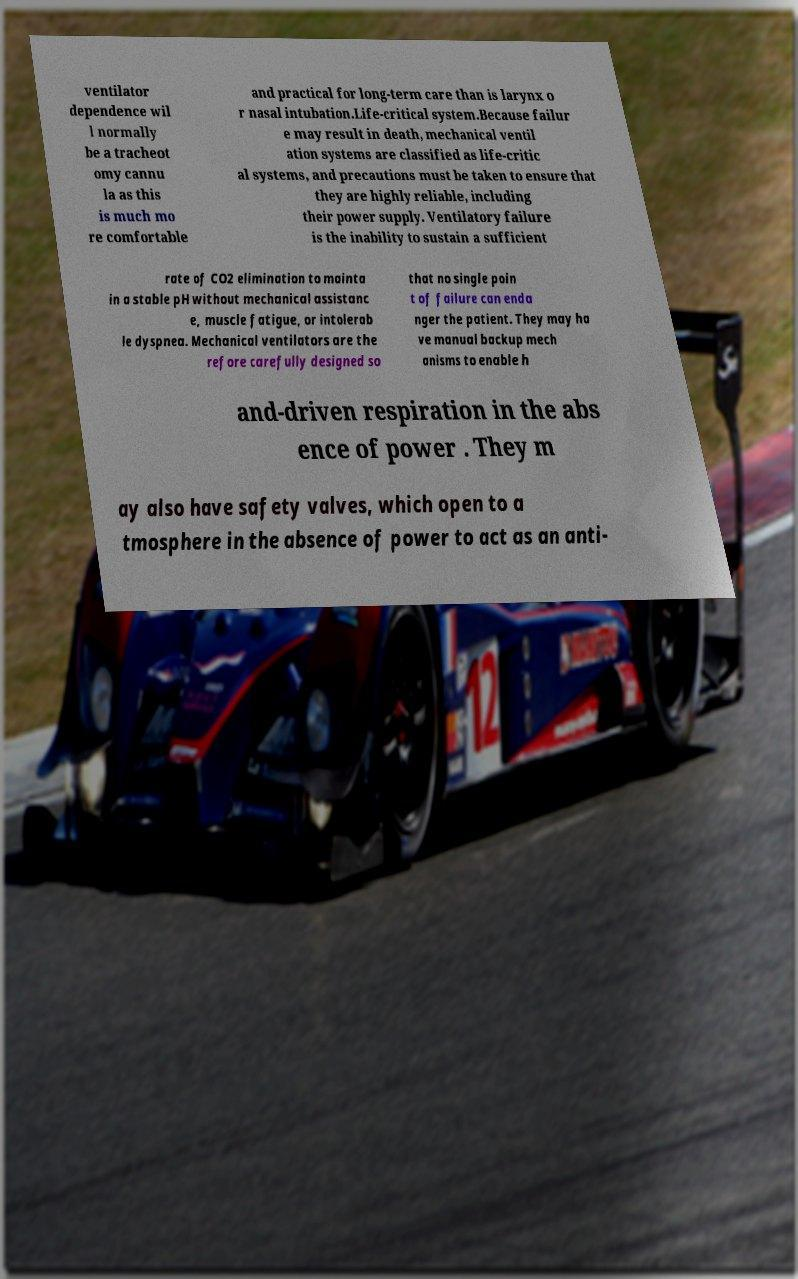For documentation purposes, I need the text within this image transcribed. Could you provide that? ventilator dependence wil l normally be a tracheot omy cannu la as this is much mo re comfortable and practical for long-term care than is larynx o r nasal intubation.Life-critical system.Because failur e may result in death, mechanical ventil ation systems are classified as life-critic al systems, and precautions must be taken to ensure that they are highly reliable, including their power supply. Ventilatory failure is the inability to sustain a sufficient rate of CO2 elimination to mainta in a stable pH without mechanical assistanc e, muscle fatigue, or intolerab le dyspnea. Mechanical ventilators are the refore carefully designed so that no single poin t of failure can enda nger the patient. They may ha ve manual backup mech anisms to enable h and-driven respiration in the abs ence of power . They m ay also have safety valves, which open to a tmosphere in the absence of power to act as an anti- 